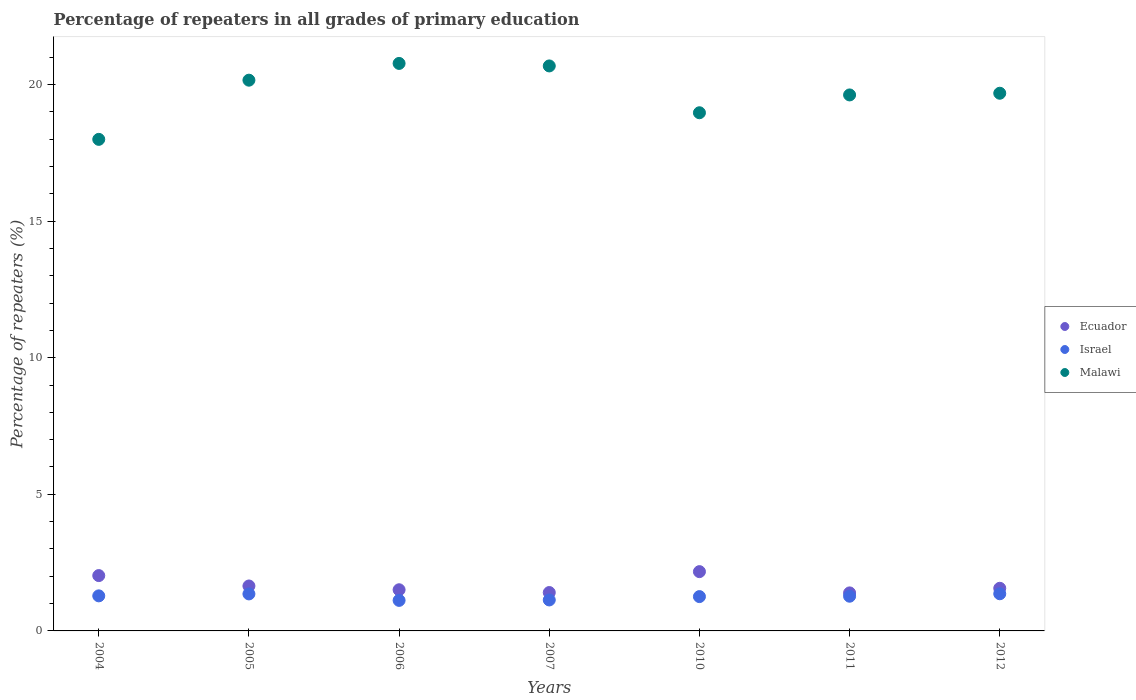How many different coloured dotlines are there?
Offer a very short reply. 3. Is the number of dotlines equal to the number of legend labels?
Offer a very short reply. Yes. What is the percentage of repeaters in Ecuador in 2004?
Provide a short and direct response. 2.03. Across all years, what is the maximum percentage of repeaters in Israel?
Offer a very short reply. 1.36. Across all years, what is the minimum percentage of repeaters in Malawi?
Your answer should be compact. 17.99. In which year was the percentage of repeaters in Malawi minimum?
Your answer should be compact. 2004. What is the total percentage of repeaters in Israel in the graph?
Your response must be concise. 8.78. What is the difference between the percentage of repeaters in Ecuador in 2006 and that in 2011?
Keep it short and to the point. 0.11. What is the difference between the percentage of repeaters in Israel in 2004 and the percentage of repeaters in Ecuador in 2010?
Ensure brevity in your answer.  -0.89. What is the average percentage of repeaters in Malawi per year?
Your answer should be compact. 19.69. In the year 2012, what is the difference between the percentage of repeaters in Ecuador and percentage of repeaters in Malawi?
Your response must be concise. -18.12. In how many years, is the percentage of repeaters in Malawi greater than 13 %?
Provide a short and direct response. 7. What is the ratio of the percentage of repeaters in Malawi in 2004 to that in 2007?
Offer a terse response. 0.87. Is the difference between the percentage of repeaters in Ecuador in 2010 and 2012 greater than the difference between the percentage of repeaters in Malawi in 2010 and 2012?
Make the answer very short. Yes. What is the difference between the highest and the second highest percentage of repeaters in Israel?
Offer a very short reply. 0.01. What is the difference between the highest and the lowest percentage of repeaters in Malawi?
Your answer should be compact. 2.78. Is the sum of the percentage of repeaters in Israel in 2006 and 2007 greater than the maximum percentage of repeaters in Malawi across all years?
Offer a terse response. No. Is it the case that in every year, the sum of the percentage of repeaters in Israel and percentage of repeaters in Malawi  is greater than the percentage of repeaters in Ecuador?
Make the answer very short. Yes. Is the percentage of repeaters in Ecuador strictly less than the percentage of repeaters in Israel over the years?
Your answer should be compact. No. Are the values on the major ticks of Y-axis written in scientific E-notation?
Ensure brevity in your answer.  No. Does the graph contain any zero values?
Your answer should be compact. No. Where does the legend appear in the graph?
Your answer should be very brief. Center right. How many legend labels are there?
Provide a succinct answer. 3. What is the title of the graph?
Provide a short and direct response. Percentage of repeaters in all grades of primary education. Does "Turkmenistan" appear as one of the legend labels in the graph?
Make the answer very short. No. What is the label or title of the X-axis?
Provide a succinct answer. Years. What is the label or title of the Y-axis?
Your answer should be compact. Percentage of repeaters (%). What is the Percentage of repeaters (%) of Ecuador in 2004?
Ensure brevity in your answer.  2.03. What is the Percentage of repeaters (%) in Israel in 2004?
Offer a terse response. 1.28. What is the Percentage of repeaters (%) of Malawi in 2004?
Give a very brief answer. 17.99. What is the Percentage of repeaters (%) in Ecuador in 2005?
Provide a succinct answer. 1.64. What is the Percentage of repeaters (%) of Israel in 2005?
Ensure brevity in your answer.  1.35. What is the Percentage of repeaters (%) in Malawi in 2005?
Provide a short and direct response. 20.16. What is the Percentage of repeaters (%) of Ecuador in 2006?
Offer a very short reply. 1.51. What is the Percentage of repeaters (%) of Israel in 2006?
Provide a short and direct response. 1.12. What is the Percentage of repeaters (%) in Malawi in 2006?
Make the answer very short. 20.77. What is the Percentage of repeaters (%) of Ecuador in 2007?
Offer a very short reply. 1.4. What is the Percentage of repeaters (%) of Israel in 2007?
Offer a terse response. 1.13. What is the Percentage of repeaters (%) of Malawi in 2007?
Make the answer very short. 20.68. What is the Percentage of repeaters (%) in Ecuador in 2010?
Provide a succinct answer. 2.17. What is the Percentage of repeaters (%) in Israel in 2010?
Your answer should be compact. 1.26. What is the Percentage of repeaters (%) of Malawi in 2010?
Provide a short and direct response. 18.97. What is the Percentage of repeaters (%) of Ecuador in 2011?
Offer a terse response. 1.39. What is the Percentage of repeaters (%) of Israel in 2011?
Make the answer very short. 1.27. What is the Percentage of repeaters (%) in Malawi in 2011?
Give a very brief answer. 19.62. What is the Percentage of repeaters (%) of Ecuador in 2012?
Your answer should be very brief. 1.56. What is the Percentage of repeaters (%) of Israel in 2012?
Give a very brief answer. 1.36. What is the Percentage of repeaters (%) of Malawi in 2012?
Give a very brief answer. 19.68. Across all years, what is the maximum Percentage of repeaters (%) in Ecuador?
Make the answer very short. 2.17. Across all years, what is the maximum Percentage of repeaters (%) in Israel?
Your answer should be very brief. 1.36. Across all years, what is the maximum Percentage of repeaters (%) in Malawi?
Your answer should be compact. 20.77. Across all years, what is the minimum Percentage of repeaters (%) in Ecuador?
Offer a terse response. 1.39. Across all years, what is the minimum Percentage of repeaters (%) of Israel?
Offer a very short reply. 1.12. Across all years, what is the minimum Percentage of repeaters (%) of Malawi?
Your answer should be very brief. 17.99. What is the total Percentage of repeaters (%) in Ecuador in the graph?
Make the answer very short. 11.7. What is the total Percentage of repeaters (%) in Israel in the graph?
Keep it short and to the point. 8.78. What is the total Percentage of repeaters (%) of Malawi in the graph?
Provide a short and direct response. 137.86. What is the difference between the Percentage of repeaters (%) of Ecuador in 2004 and that in 2005?
Make the answer very short. 0.38. What is the difference between the Percentage of repeaters (%) of Israel in 2004 and that in 2005?
Make the answer very short. -0.07. What is the difference between the Percentage of repeaters (%) in Malawi in 2004 and that in 2005?
Give a very brief answer. -2.17. What is the difference between the Percentage of repeaters (%) in Ecuador in 2004 and that in 2006?
Ensure brevity in your answer.  0.52. What is the difference between the Percentage of repeaters (%) in Israel in 2004 and that in 2006?
Give a very brief answer. 0.17. What is the difference between the Percentage of repeaters (%) of Malawi in 2004 and that in 2006?
Your answer should be very brief. -2.78. What is the difference between the Percentage of repeaters (%) of Ecuador in 2004 and that in 2007?
Ensure brevity in your answer.  0.62. What is the difference between the Percentage of repeaters (%) of Israel in 2004 and that in 2007?
Offer a terse response. 0.15. What is the difference between the Percentage of repeaters (%) in Malawi in 2004 and that in 2007?
Make the answer very short. -2.69. What is the difference between the Percentage of repeaters (%) of Ecuador in 2004 and that in 2010?
Your response must be concise. -0.14. What is the difference between the Percentage of repeaters (%) of Israel in 2004 and that in 2010?
Ensure brevity in your answer.  0.03. What is the difference between the Percentage of repeaters (%) in Malawi in 2004 and that in 2010?
Your response must be concise. -0.97. What is the difference between the Percentage of repeaters (%) of Ecuador in 2004 and that in 2011?
Offer a very short reply. 0.63. What is the difference between the Percentage of repeaters (%) of Israel in 2004 and that in 2011?
Your answer should be compact. 0.01. What is the difference between the Percentage of repeaters (%) in Malawi in 2004 and that in 2011?
Give a very brief answer. -1.63. What is the difference between the Percentage of repeaters (%) in Ecuador in 2004 and that in 2012?
Offer a terse response. 0.46. What is the difference between the Percentage of repeaters (%) of Israel in 2004 and that in 2012?
Your answer should be very brief. -0.08. What is the difference between the Percentage of repeaters (%) in Malawi in 2004 and that in 2012?
Provide a short and direct response. -1.69. What is the difference between the Percentage of repeaters (%) in Ecuador in 2005 and that in 2006?
Keep it short and to the point. 0.14. What is the difference between the Percentage of repeaters (%) of Israel in 2005 and that in 2006?
Provide a short and direct response. 0.24. What is the difference between the Percentage of repeaters (%) in Malawi in 2005 and that in 2006?
Your answer should be compact. -0.61. What is the difference between the Percentage of repeaters (%) of Ecuador in 2005 and that in 2007?
Offer a very short reply. 0.24. What is the difference between the Percentage of repeaters (%) of Israel in 2005 and that in 2007?
Your answer should be compact. 0.22. What is the difference between the Percentage of repeaters (%) in Malawi in 2005 and that in 2007?
Your response must be concise. -0.52. What is the difference between the Percentage of repeaters (%) in Ecuador in 2005 and that in 2010?
Your answer should be compact. -0.53. What is the difference between the Percentage of repeaters (%) in Israel in 2005 and that in 2010?
Ensure brevity in your answer.  0.1. What is the difference between the Percentage of repeaters (%) in Malawi in 2005 and that in 2010?
Make the answer very short. 1.19. What is the difference between the Percentage of repeaters (%) in Ecuador in 2005 and that in 2011?
Give a very brief answer. 0.25. What is the difference between the Percentage of repeaters (%) in Israel in 2005 and that in 2011?
Give a very brief answer. 0.08. What is the difference between the Percentage of repeaters (%) of Malawi in 2005 and that in 2011?
Keep it short and to the point. 0.54. What is the difference between the Percentage of repeaters (%) of Ecuador in 2005 and that in 2012?
Keep it short and to the point. 0.08. What is the difference between the Percentage of repeaters (%) of Israel in 2005 and that in 2012?
Your answer should be very brief. -0.01. What is the difference between the Percentage of repeaters (%) of Malawi in 2005 and that in 2012?
Offer a terse response. 0.48. What is the difference between the Percentage of repeaters (%) of Ecuador in 2006 and that in 2007?
Your response must be concise. 0.1. What is the difference between the Percentage of repeaters (%) in Israel in 2006 and that in 2007?
Make the answer very short. -0.02. What is the difference between the Percentage of repeaters (%) in Malawi in 2006 and that in 2007?
Ensure brevity in your answer.  0.09. What is the difference between the Percentage of repeaters (%) in Ecuador in 2006 and that in 2010?
Keep it short and to the point. -0.66. What is the difference between the Percentage of repeaters (%) in Israel in 2006 and that in 2010?
Your answer should be compact. -0.14. What is the difference between the Percentage of repeaters (%) of Malawi in 2006 and that in 2010?
Give a very brief answer. 1.81. What is the difference between the Percentage of repeaters (%) of Ecuador in 2006 and that in 2011?
Provide a succinct answer. 0.11. What is the difference between the Percentage of repeaters (%) in Israel in 2006 and that in 2011?
Offer a terse response. -0.15. What is the difference between the Percentage of repeaters (%) of Malawi in 2006 and that in 2011?
Your answer should be compact. 1.15. What is the difference between the Percentage of repeaters (%) in Ecuador in 2006 and that in 2012?
Provide a short and direct response. -0.05. What is the difference between the Percentage of repeaters (%) of Israel in 2006 and that in 2012?
Your answer should be compact. -0.24. What is the difference between the Percentage of repeaters (%) of Malawi in 2006 and that in 2012?
Keep it short and to the point. 1.09. What is the difference between the Percentage of repeaters (%) in Ecuador in 2007 and that in 2010?
Offer a terse response. -0.77. What is the difference between the Percentage of repeaters (%) in Israel in 2007 and that in 2010?
Provide a succinct answer. -0.12. What is the difference between the Percentage of repeaters (%) of Malawi in 2007 and that in 2010?
Keep it short and to the point. 1.71. What is the difference between the Percentage of repeaters (%) in Ecuador in 2007 and that in 2011?
Offer a terse response. 0.01. What is the difference between the Percentage of repeaters (%) in Israel in 2007 and that in 2011?
Offer a terse response. -0.14. What is the difference between the Percentage of repeaters (%) of Malawi in 2007 and that in 2011?
Offer a terse response. 1.06. What is the difference between the Percentage of repeaters (%) of Ecuador in 2007 and that in 2012?
Your answer should be compact. -0.16. What is the difference between the Percentage of repeaters (%) of Israel in 2007 and that in 2012?
Ensure brevity in your answer.  -0.23. What is the difference between the Percentage of repeaters (%) in Ecuador in 2010 and that in 2011?
Provide a short and direct response. 0.78. What is the difference between the Percentage of repeaters (%) of Israel in 2010 and that in 2011?
Offer a very short reply. -0.01. What is the difference between the Percentage of repeaters (%) of Malawi in 2010 and that in 2011?
Offer a terse response. -0.65. What is the difference between the Percentage of repeaters (%) of Ecuador in 2010 and that in 2012?
Your answer should be very brief. 0.61. What is the difference between the Percentage of repeaters (%) in Israel in 2010 and that in 2012?
Make the answer very short. -0.1. What is the difference between the Percentage of repeaters (%) in Malawi in 2010 and that in 2012?
Provide a succinct answer. -0.71. What is the difference between the Percentage of repeaters (%) in Ecuador in 2011 and that in 2012?
Provide a succinct answer. -0.17. What is the difference between the Percentage of repeaters (%) of Israel in 2011 and that in 2012?
Provide a succinct answer. -0.09. What is the difference between the Percentage of repeaters (%) in Malawi in 2011 and that in 2012?
Provide a short and direct response. -0.06. What is the difference between the Percentage of repeaters (%) of Ecuador in 2004 and the Percentage of repeaters (%) of Israel in 2005?
Provide a short and direct response. 0.67. What is the difference between the Percentage of repeaters (%) in Ecuador in 2004 and the Percentage of repeaters (%) in Malawi in 2005?
Give a very brief answer. -18.13. What is the difference between the Percentage of repeaters (%) in Israel in 2004 and the Percentage of repeaters (%) in Malawi in 2005?
Your answer should be compact. -18.87. What is the difference between the Percentage of repeaters (%) of Ecuador in 2004 and the Percentage of repeaters (%) of Israel in 2006?
Give a very brief answer. 0.91. What is the difference between the Percentage of repeaters (%) in Ecuador in 2004 and the Percentage of repeaters (%) in Malawi in 2006?
Make the answer very short. -18.75. What is the difference between the Percentage of repeaters (%) in Israel in 2004 and the Percentage of repeaters (%) in Malawi in 2006?
Your response must be concise. -19.49. What is the difference between the Percentage of repeaters (%) of Ecuador in 2004 and the Percentage of repeaters (%) of Israel in 2007?
Ensure brevity in your answer.  0.89. What is the difference between the Percentage of repeaters (%) in Ecuador in 2004 and the Percentage of repeaters (%) in Malawi in 2007?
Provide a short and direct response. -18.65. What is the difference between the Percentage of repeaters (%) of Israel in 2004 and the Percentage of repeaters (%) of Malawi in 2007?
Ensure brevity in your answer.  -19.4. What is the difference between the Percentage of repeaters (%) of Ecuador in 2004 and the Percentage of repeaters (%) of Israel in 2010?
Offer a very short reply. 0.77. What is the difference between the Percentage of repeaters (%) of Ecuador in 2004 and the Percentage of repeaters (%) of Malawi in 2010?
Your answer should be very brief. -16.94. What is the difference between the Percentage of repeaters (%) in Israel in 2004 and the Percentage of repeaters (%) in Malawi in 2010?
Give a very brief answer. -17.68. What is the difference between the Percentage of repeaters (%) of Ecuador in 2004 and the Percentage of repeaters (%) of Israel in 2011?
Provide a succinct answer. 0.75. What is the difference between the Percentage of repeaters (%) of Ecuador in 2004 and the Percentage of repeaters (%) of Malawi in 2011?
Make the answer very short. -17.59. What is the difference between the Percentage of repeaters (%) of Israel in 2004 and the Percentage of repeaters (%) of Malawi in 2011?
Make the answer very short. -18.33. What is the difference between the Percentage of repeaters (%) of Ecuador in 2004 and the Percentage of repeaters (%) of Israel in 2012?
Ensure brevity in your answer.  0.67. What is the difference between the Percentage of repeaters (%) of Ecuador in 2004 and the Percentage of repeaters (%) of Malawi in 2012?
Give a very brief answer. -17.65. What is the difference between the Percentage of repeaters (%) in Israel in 2004 and the Percentage of repeaters (%) in Malawi in 2012?
Keep it short and to the point. -18.4. What is the difference between the Percentage of repeaters (%) of Ecuador in 2005 and the Percentage of repeaters (%) of Israel in 2006?
Ensure brevity in your answer.  0.53. What is the difference between the Percentage of repeaters (%) of Ecuador in 2005 and the Percentage of repeaters (%) of Malawi in 2006?
Your answer should be very brief. -19.13. What is the difference between the Percentage of repeaters (%) in Israel in 2005 and the Percentage of repeaters (%) in Malawi in 2006?
Give a very brief answer. -19.42. What is the difference between the Percentage of repeaters (%) in Ecuador in 2005 and the Percentage of repeaters (%) in Israel in 2007?
Offer a very short reply. 0.51. What is the difference between the Percentage of repeaters (%) in Ecuador in 2005 and the Percentage of repeaters (%) in Malawi in 2007?
Make the answer very short. -19.03. What is the difference between the Percentage of repeaters (%) in Israel in 2005 and the Percentage of repeaters (%) in Malawi in 2007?
Give a very brief answer. -19.32. What is the difference between the Percentage of repeaters (%) of Ecuador in 2005 and the Percentage of repeaters (%) of Israel in 2010?
Your answer should be compact. 0.39. What is the difference between the Percentage of repeaters (%) in Ecuador in 2005 and the Percentage of repeaters (%) in Malawi in 2010?
Provide a short and direct response. -17.32. What is the difference between the Percentage of repeaters (%) of Israel in 2005 and the Percentage of repeaters (%) of Malawi in 2010?
Ensure brevity in your answer.  -17.61. What is the difference between the Percentage of repeaters (%) of Ecuador in 2005 and the Percentage of repeaters (%) of Israel in 2011?
Offer a very short reply. 0.37. What is the difference between the Percentage of repeaters (%) of Ecuador in 2005 and the Percentage of repeaters (%) of Malawi in 2011?
Ensure brevity in your answer.  -17.97. What is the difference between the Percentage of repeaters (%) of Israel in 2005 and the Percentage of repeaters (%) of Malawi in 2011?
Your answer should be very brief. -18.26. What is the difference between the Percentage of repeaters (%) of Ecuador in 2005 and the Percentage of repeaters (%) of Israel in 2012?
Your answer should be very brief. 0.28. What is the difference between the Percentage of repeaters (%) in Ecuador in 2005 and the Percentage of repeaters (%) in Malawi in 2012?
Ensure brevity in your answer.  -18.03. What is the difference between the Percentage of repeaters (%) in Israel in 2005 and the Percentage of repeaters (%) in Malawi in 2012?
Provide a succinct answer. -18.32. What is the difference between the Percentage of repeaters (%) of Ecuador in 2006 and the Percentage of repeaters (%) of Israel in 2007?
Offer a terse response. 0.37. What is the difference between the Percentage of repeaters (%) in Ecuador in 2006 and the Percentage of repeaters (%) in Malawi in 2007?
Your response must be concise. -19.17. What is the difference between the Percentage of repeaters (%) of Israel in 2006 and the Percentage of repeaters (%) of Malawi in 2007?
Give a very brief answer. -19.56. What is the difference between the Percentage of repeaters (%) in Ecuador in 2006 and the Percentage of repeaters (%) in Israel in 2010?
Your answer should be compact. 0.25. What is the difference between the Percentage of repeaters (%) in Ecuador in 2006 and the Percentage of repeaters (%) in Malawi in 2010?
Keep it short and to the point. -17.46. What is the difference between the Percentage of repeaters (%) in Israel in 2006 and the Percentage of repeaters (%) in Malawi in 2010?
Make the answer very short. -17.85. What is the difference between the Percentage of repeaters (%) of Ecuador in 2006 and the Percentage of repeaters (%) of Israel in 2011?
Give a very brief answer. 0.24. What is the difference between the Percentage of repeaters (%) in Ecuador in 2006 and the Percentage of repeaters (%) in Malawi in 2011?
Offer a very short reply. -18.11. What is the difference between the Percentage of repeaters (%) of Israel in 2006 and the Percentage of repeaters (%) of Malawi in 2011?
Ensure brevity in your answer.  -18.5. What is the difference between the Percentage of repeaters (%) in Ecuador in 2006 and the Percentage of repeaters (%) in Israel in 2012?
Make the answer very short. 0.15. What is the difference between the Percentage of repeaters (%) in Ecuador in 2006 and the Percentage of repeaters (%) in Malawi in 2012?
Your answer should be very brief. -18.17. What is the difference between the Percentage of repeaters (%) of Israel in 2006 and the Percentage of repeaters (%) of Malawi in 2012?
Make the answer very short. -18.56. What is the difference between the Percentage of repeaters (%) of Ecuador in 2007 and the Percentage of repeaters (%) of Israel in 2010?
Your answer should be very brief. 0.15. What is the difference between the Percentage of repeaters (%) in Ecuador in 2007 and the Percentage of repeaters (%) in Malawi in 2010?
Keep it short and to the point. -17.56. What is the difference between the Percentage of repeaters (%) of Israel in 2007 and the Percentage of repeaters (%) of Malawi in 2010?
Offer a very short reply. -17.83. What is the difference between the Percentage of repeaters (%) in Ecuador in 2007 and the Percentage of repeaters (%) in Israel in 2011?
Keep it short and to the point. 0.13. What is the difference between the Percentage of repeaters (%) of Ecuador in 2007 and the Percentage of repeaters (%) of Malawi in 2011?
Give a very brief answer. -18.21. What is the difference between the Percentage of repeaters (%) in Israel in 2007 and the Percentage of repeaters (%) in Malawi in 2011?
Offer a terse response. -18.48. What is the difference between the Percentage of repeaters (%) in Ecuador in 2007 and the Percentage of repeaters (%) in Israel in 2012?
Make the answer very short. 0.04. What is the difference between the Percentage of repeaters (%) of Ecuador in 2007 and the Percentage of repeaters (%) of Malawi in 2012?
Offer a very short reply. -18.27. What is the difference between the Percentage of repeaters (%) in Israel in 2007 and the Percentage of repeaters (%) in Malawi in 2012?
Keep it short and to the point. -18.55. What is the difference between the Percentage of repeaters (%) in Ecuador in 2010 and the Percentage of repeaters (%) in Israel in 2011?
Your response must be concise. 0.9. What is the difference between the Percentage of repeaters (%) in Ecuador in 2010 and the Percentage of repeaters (%) in Malawi in 2011?
Make the answer very short. -17.45. What is the difference between the Percentage of repeaters (%) of Israel in 2010 and the Percentage of repeaters (%) of Malawi in 2011?
Offer a terse response. -18.36. What is the difference between the Percentage of repeaters (%) of Ecuador in 2010 and the Percentage of repeaters (%) of Israel in 2012?
Make the answer very short. 0.81. What is the difference between the Percentage of repeaters (%) in Ecuador in 2010 and the Percentage of repeaters (%) in Malawi in 2012?
Keep it short and to the point. -17.51. What is the difference between the Percentage of repeaters (%) in Israel in 2010 and the Percentage of repeaters (%) in Malawi in 2012?
Your answer should be very brief. -18.42. What is the difference between the Percentage of repeaters (%) in Ecuador in 2011 and the Percentage of repeaters (%) in Israel in 2012?
Offer a very short reply. 0.03. What is the difference between the Percentage of repeaters (%) of Ecuador in 2011 and the Percentage of repeaters (%) of Malawi in 2012?
Provide a short and direct response. -18.29. What is the difference between the Percentage of repeaters (%) of Israel in 2011 and the Percentage of repeaters (%) of Malawi in 2012?
Make the answer very short. -18.41. What is the average Percentage of repeaters (%) of Ecuador per year?
Give a very brief answer. 1.67. What is the average Percentage of repeaters (%) in Israel per year?
Your response must be concise. 1.25. What is the average Percentage of repeaters (%) in Malawi per year?
Keep it short and to the point. 19.69. In the year 2004, what is the difference between the Percentage of repeaters (%) of Ecuador and Percentage of repeaters (%) of Israel?
Keep it short and to the point. 0.74. In the year 2004, what is the difference between the Percentage of repeaters (%) of Ecuador and Percentage of repeaters (%) of Malawi?
Provide a succinct answer. -15.97. In the year 2004, what is the difference between the Percentage of repeaters (%) in Israel and Percentage of repeaters (%) in Malawi?
Ensure brevity in your answer.  -16.71. In the year 2005, what is the difference between the Percentage of repeaters (%) in Ecuador and Percentage of repeaters (%) in Israel?
Ensure brevity in your answer.  0.29. In the year 2005, what is the difference between the Percentage of repeaters (%) of Ecuador and Percentage of repeaters (%) of Malawi?
Keep it short and to the point. -18.51. In the year 2005, what is the difference between the Percentage of repeaters (%) of Israel and Percentage of repeaters (%) of Malawi?
Provide a succinct answer. -18.8. In the year 2006, what is the difference between the Percentage of repeaters (%) of Ecuador and Percentage of repeaters (%) of Israel?
Ensure brevity in your answer.  0.39. In the year 2006, what is the difference between the Percentage of repeaters (%) in Ecuador and Percentage of repeaters (%) in Malawi?
Your answer should be very brief. -19.26. In the year 2006, what is the difference between the Percentage of repeaters (%) of Israel and Percentage of repeaters (%) of Malawi?
Your answer should be compact. -19.65. In the year 2007, what is the difference between the Percentage of repeaters (%) of Ecuador and Percentage of repeaters (%) of Israel?
Provide a short and direct response. 0.27. In the year 2007, what is the difference between the Percentage of repeaters (%) of Ecuador and Percentage of repeaters (%) of Malawi?
Your response must be concise. -19.27. In the year 2007, what is the difference between the Percentage of repeaters (%) of Israel and Percentage of repeaters (%) of Malawi?
Your answer should be compact. -19.55. In the year 2010, what is the difference between the Percentage of repeaters (%) of Ecuador and Percentage of repeaters (%) of Israel?
Your response must be concise. 0.91. In the year 2010, what is the difference between the Percentage of repeaters (%) of Ecuador and Percentage of repeaters (%) of Malawi?
Make the answer very short. -16.8. In the year 2010, what is the difference between the Percentage of repeaters (%) in Israel and Percentage of repeaters (%) in Malawi?
Provide a succinct answer. -17.71. In the year 2011, what is the difference between the Percentage of repeaters (%) in Ecuador and Percentage of repeaters (%) in Israel?
Give a very brief answer. 0.12. In the year 2011, what is the difference between the Percentage of repeaters (%) of Ecuador and Percentage of repeaters (%) of Malawi?
Keep it short and to the point. -18.23. In the year 2011, what is the difference between the Percentage of repeaters (%) of Israel and Percentage of repeaters (%) of Malawi?
Provide a short and direct response. -18.35. In the year 2012, what is the difference between the Percentage of repeaters (%) of Ecuador and Percentage of repeaters (%) of Israel?
Offer a terse response. 0.2. In the year 2012, what is the difference between the Percentage of repeaters (%) in Ecuador and Percentage of repeaters (%) in Malawi?
Give a very brief answer. -18.12. In the year 2012, what is the difference between the Percentage of repeaters (%) of Israel and Percentage of repeaters (%) of Malawi?
Offer a terse response. -18.32. What is the ratio of the Percentage of repeaters (%) in Ecuador in 2004 to that in 2005?
Provide a succinct answer. 1.23. What is the ratio of the Percentage of repeaters (%) of Israel in 2004 to that in 2005?
Make the answer very short. 0.95. What is the ratio of the Percentage of repeaters (%) in Malawi in 2004 to that in 2005?
Your response must be concise. 0.89. What is the ratio of the Percentage of repeaters (%) of Ecuador in 2004 to that in 2006?
Offer a terse response. 1.34. What is the ratio of the Percentage of repeaters (%) of Israel in 2004 to that in 2006?
Provide a short and direct response. 1.15. What is the ratio of the Percentage of repeaters (%) in Malawi in 2004 to that in 2006?
Your answer should be compact. 0.87. What is the ratio of the Percentage of repeaters (%) in Ecuador in 2004 to that in 2007?
Offer a terse response. 1.44. What is the ratio of the Percentage of repeaters (%) in Israel in 2004 to that in 2007?
Offer a very short reply. 1.13. What is the ratio of the Percentage of repeaters (%) of Malawi in 2004 to that in 2007?
Make the answer very short. 0.87. What is the ratio of the Percentage of repeaters (%) of Israel in 2004 to that in 2010?
Keep it short and to the point. 1.02. What is the ratio of the Percentage of repeaters (%) in Malawi in 2004 to that in 2010?
Your answer should be compact. 0.95. What is the ratio of the Percentage of repeaters (%) in Ecuador in 2004 to that in 2011?
Keep it short and to the point. 1.46. What is the ratio of the Percentage of repeaters (%) of Israel in 2004 to that in 2011?
Give a very brief answer. 1.01. What is the ratio of the Percentage of repeaters (%) of Malawi in 2004 to that in 2011?
Give a very brief answer. 0.92. What is the ratio of the Percentage of repeaters (%) in Ecuador in 2004 to that in 2012?
Make the answer very short. 1.3. What is the ratio of the Percentage of repeaters (%) in Israel in 2004 to that in 2012?
Your answer should be compact. 0.94. What is the ratio of the Percentage of repeaters (%) in Malawi in 2004 to that in 2012?
Provide a short and direct response. 0.91. What is the ratio of the Percentage of repeaters (%) of Ecuador in 2005 to that in 2006?
Ensure brevity in your answer.  1.09. What is the ratio of the Percentage of repeaters (%) in Israel in 2005 to that in 2006?
Keep it short and to the point. 1.21. What is the ratio of the Percentage of repeaters (%) of Malawi in 2005 to that in 2006?
Provide a succinct answer. 0.97. What is the ratio of the Percentage of repeaters (%) in Ecuador in 2005 to that in 2007?
Make the answer very short. 1.17. What is the ratio of the Percentage of repeaters (%) in Israel in 2005 to that in 2007?
Provide a succinct answer. 1.2. What is the ratio of the Percentage of repeaters (%) in Malawi in 2005 to that in 2007?
Offer a very short reply. 0.97. What is the ratio of the Percentage of repeaters (%) of Ecuador in 2005 to that in 2010?
Ensure brevity in your answer.  0.76. What is the ratio of the Percentage of repeaters (%) in Israel in 2005 to that in 2010?
Keep it short and to the point. 1.08. What is the ratio of the Percentage of repeaters (%) of Malawi in 2005 to that in 2010?
Offer a terse response. 1.06. What is the ratio of the Percentage of repeaters (%) of Ecuador in 2005 to that in 2011?
Your response must be concise. 1.18. What is the ratio of the Percentage of repeaters (%) in Israel in 2005 to that in 2011?
Your answer should be very brief. 1.07. What is the ratio of the Percentage of repeaters (%) in Malawi in 2005 to that in 2011?
Give a very brief answer. 1.03. What is the ratio of the Percentage of repeaters (%) of Ecuador in 2005 to that in 2012?
Provide a short and direct response. 1.05. What is the ratio of the Percentage of repeaters (%) of Israel in 2005 to that in 2012?
Give a very brief answer. 1. What is the ratio of the Percentage of repeaters (%) in Malawi in 2005 to that in 2012?
Offer a terse response. 1.02. What is the ratio of the Percentage of repeaters (%) in Ecuador in 2006 to that in 2007?
Ensure brevity in your answer.  1.07. What is the ratio of the Percentage of repeaters (%) of Israel in 2006 to that in 2007?
Offer a very short reply. 0.99. What is the ratio of the Percentage of repeaters (%) in Ecuador in 2006 to that in 2010?
Your answer should be compact. 0.69. What is the ratio of the Percentage of repeaters (%) of Israel in 2006 to that in 2010?
Make the answer very short. 0.89. What is the ratio of the Percentage of repeaters (%) in Malawi in 2006 to that in 2010?
Make the answer very short. 1.1. What is the ratio of the Percentage of repeaters (%) in Ecuador in 2006 to that in 2011?
Provide a short and direct response. 1.08. What is the ratio of the Percentage of repeaters (%) in Israel in 2006 to that in 2011?
Your answer should be very brief. 0.88. What is the ratio of the Percentage of repeaters (%) in Malawi in 2006 to that in 2011?
Keep it short and to the point. 1.06. What is the ratio of the Percentage of repeaters (%) in Ecuador in 2006 to that in 2012?
Offer a terse response. 0.97. What is the ratio of the Percentage of repeaters (%) of Israel in 2006 to that in 2012?
Your response must be concise. 0.82. What is the ratio of the Percentage of repeaters (%) of Malawi in 2006 to that in 2012?
Your answer should be compact. 1.06. What is the ratio of the Percentage of repeaters (%) in Ecuador in 2007 to that in 2010?
Make the answer very short. 0.65. What is the ratio of the Percentage of repeaters (%) of Israel in 2007 to that in 2010?
Provide a succinct answer. 0.9. What is the ratio of the Percentage of repeaters (%) of Malawi in 2007 to that in 2010?
Your answer should be compact. 1.09. What is the ratio of the Percentage of repeaters (%) in Ecuador in 2007 to that in 2011?
Your answer should be compact. 1.01. What is the ratio of the Percentage of repeaters (%) in Israel in 2007 to that in 2011?
Your response must be concise. 0.89. What is the ratio of the Percentage of repeaters (%) in Malawi in 2007 to that in 2011?
Ensure brevity in your answer.  1.05. What is the ratio of the Percentage of repeaters (%) in Ecuador in 2007 to that in 2012?
Your answer should be very brief. 0.9. What is the ratio of the Percentage of repeaters (%) in Israel in 2007 to that in 2012?
Keep it short and to the point. 0.83. What is the ratio of the Percentage of repeaters (%) of Malawi in 2007 to that in 2012?
Give a very brief answer. 1.05. What is the ratio of the Percentage of repeaters (%) in Ecuador in 2010 to that in 2011?
Keep it short and to the point. 1.56. What is the ratio of the Percentage of repeaters (%) of Israel in 2010 to that in 2011?
Your response must be concise. 0.99. What is the ratio of the Percentage of repeaters (%) in Malawi in 2010 to that in 2011?
Your answer should be very brief. 0.97. What is the ratio of the Percentage of repeaters (%) in Ecuador in 2010 to that in 2012?
Ensure brevity in your answer.  1.39. What is the ratio of the Percentage of repeaters (%) in Israel in 2010 to that in 2012?
Ensure brevity in your answer.  0.92. What is the ratio of the Percentage of repeaters (%) of Malawi in 2010 to that in 2012?
Provide a short and direct response. 0.96. What is the ratio of the Percentage of repeaters (%) in Ecuador in 2011 to that in 2012?
Your response must be concise. 0.89. What is the ratio of the Percentage of repeaters (%) of Israel in 2011 to that in 2012?
Provide a succinct answer. 0.93. What is the ratio of the Percentage of repeaters (%) of Malawi in 2011 to that in 2012?
Make the answer very short. 1. What is the difference between the highest and the second highest Percentage of repeaters (%) in Ecuador?
Make the answer very short. 0.14. What is the difference between the highest and the second highest Percentage of repeaters (%) in Israel?
Keep it short and to the point. 0.01. What is the difference between the highest and the second highest Percentage of repeaters (%) in Malawi?
Provide a short and direct response. 0.09. What is the difference between the highest and the lowest Percentage of repeaters (%) in Ecuador?
Keep it short and to the point. 0.78. What is the difference between the highest and the lowest Percentage of repeaters (%) in Israel?
Your response must be concise. 0.24. What is the difference between the highest and the lowest Percentage of repeaters (%) of Malawi?
Your response must be concise. 2.78. 